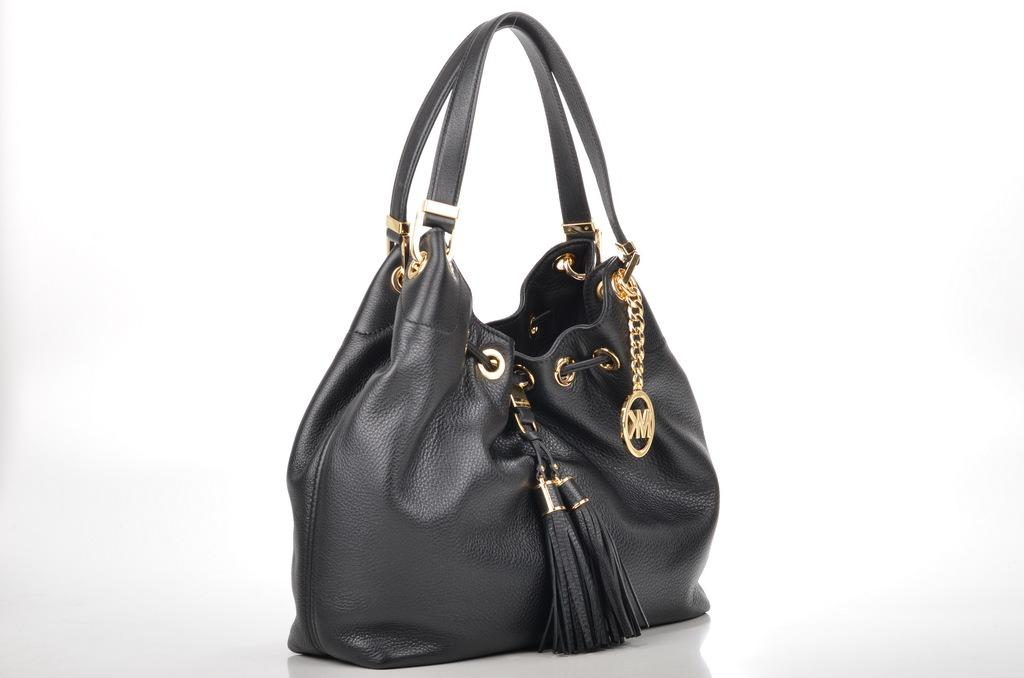What is the color of the bag in the image? The bag is black in color. What material is the bag made of? The bag is made of leather. What type of government is depicted in the image? There is no government depicted in the image; it only shows a black leather bag. How does the icicle affect the appearance of the bag in the image? There is no icicle present in the image, so it cannot affect the appearance of the bag. 